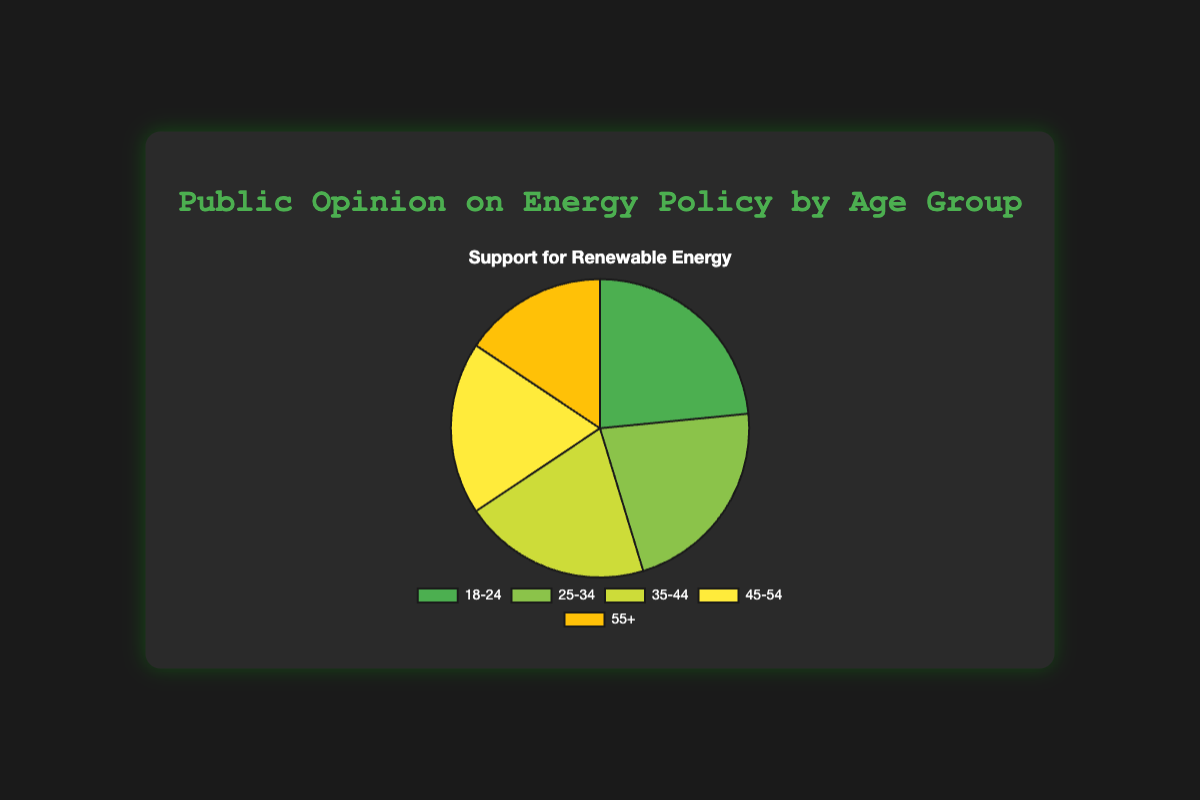What's the most supported energy policy for the age group 18-24? The chart shows that the proportion of support for renewable energy, support for fossil fuels, and neutral views for each age group. For the 18-24 age group, support for renewable energy is the highest at 75%.
Answer: Renewable energy Which age group has the lowest support for renewable energy? By looking at the chart, the 55+ age group has the lowest support for renewable energy at 50%.
Answer: 55+ What is the percentage difference in support for renewable energy between the 18-24 and 55+ age groups? The support for renewable energy is 75% for the 18-24 age group and 50% for the 55+ age group. The difference is 75% - 50% = 25%.
Answer: 25% Which age group shows the highest support for fossil fuels? The chart shows that the 55+ age group has the highest support for fossil fuels at 30%.
Answer: 55+ Compare the support for renewable energy and fossil fuels within the 45-54 age group. For the 45-54 age group, support for renewable energy is 60% and support for fossil fuels is 25%. Thus, support for renewable energy is higher.
Answer: Support for renewable energy is higher How many age groups have a support percentage for renewable energy higher than 60%? The age groups that support renewable energy higher than 60% are 18-24 (75%), 25-34 (70%), and 35-44 (65%). Thus, there are 3 age groups.
Answer: 3 What is the average support for renewable energy across all age groups? Summing up the support percentages for renewable energy (75% for 18-24, 70% for 25-34, 65% for 35-44, 60% for 45-54, and 50% for 55+) gives 320%. Dividing by 5 (the number of age groups) gives an average of 64%.
Answer: 64% Which color represents the age group that supports renewable energy the most? The color representing the 18-24 age group, which supports renewable energy the most at 75%, is green.
Answer: Green Compare the support for renewable energy between the 25-34 and 45-54 age groups. The 25-34 age group supports renewable energy at 70%, while the 45-54 age group supports it at 60%. Thus, 25-34 support is higher by 10%.
Answer: 25-34 support is higher by 10% Is the support for renewable energy equal for any two age groups? The chart shows that no two age groups have the same support percentage for renewable energy. Each age group has different levels of support.
Answer: No 